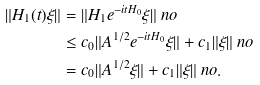Convert formula to latex. <formula><loc_0><loc_0><loc_500><loc_500>\| H _ { 1 } ( t ) \xi \| & = \| H _ { 1 } e ^ { - i t H _ { 0 } } \xi \| \ n o \\ & \leq c _ { 0 } \| A ^ { 1 / 2 } e ^ { - i t H _ { 0 } } \xi \| + c _ { 1 } \| \xi \| \ n o \\ & = c _ { 0 } \| A ^ { 1 / 2 } \xi \| + c _ { 1 } \| \xi \| \ n o .</formula> 